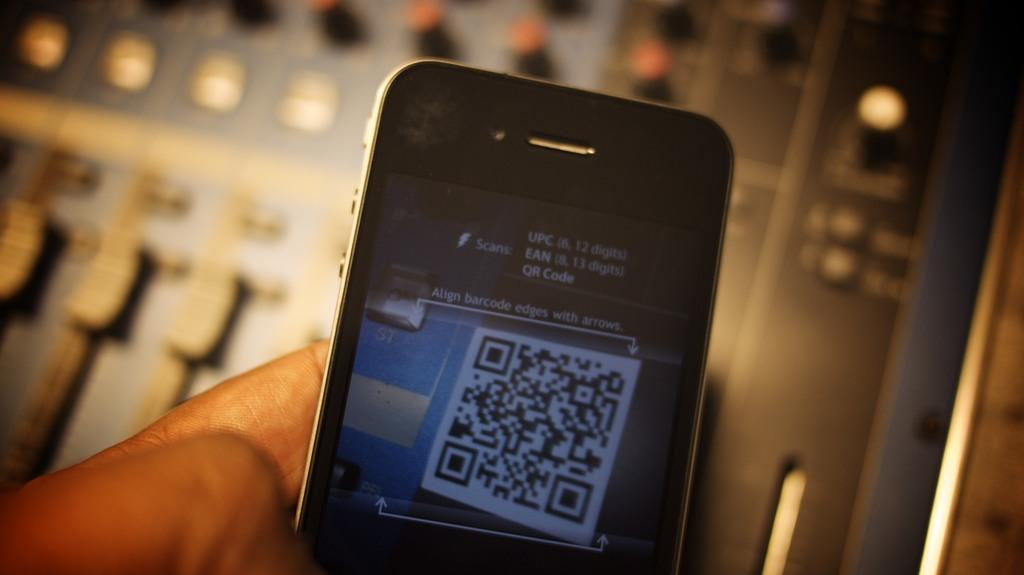<image>
Present a compact description of the photo's key features. A QR code and instructions to align the barcode edges with the arrows. 